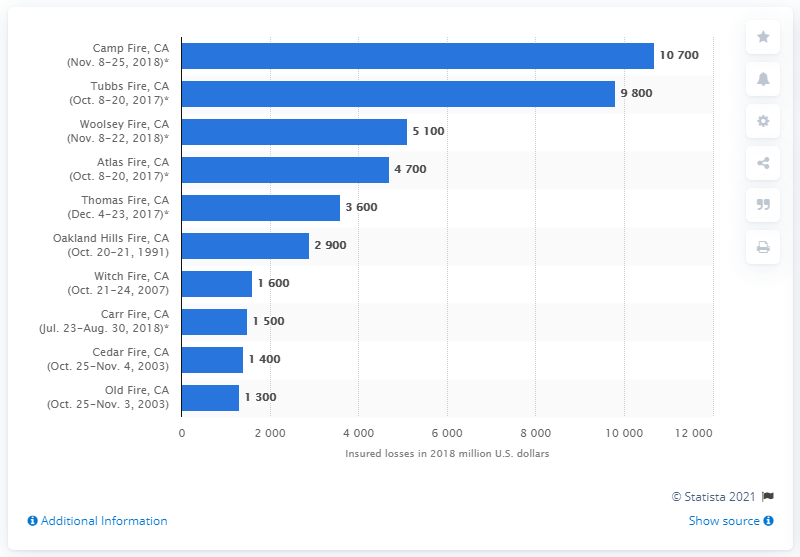Indicate a few pertinent items in this graphic. The Camp Fire resulted in insured losses of approximately $10,700. 